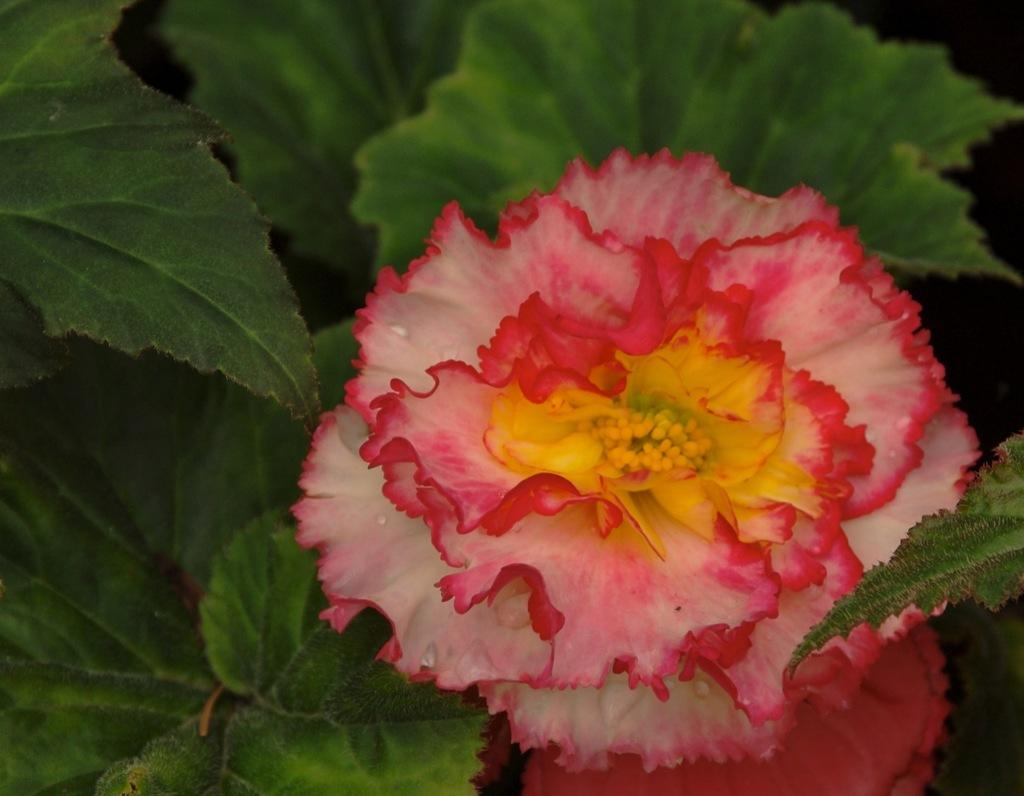What type of plants can be seen in the image? There are flowers and leaves in the image. Can you describe the appearance of the flowers? Unfortunately, the specific appearance of the flowers cannot be determined from the provided facts. Are there any other elements in the image besides the flowers and leaves? No additional elements are mentioned in the provided facts. How many trucks are parked on the throne in the image? There are no trucks or thrones present in the image; it features flowers and leaves. 